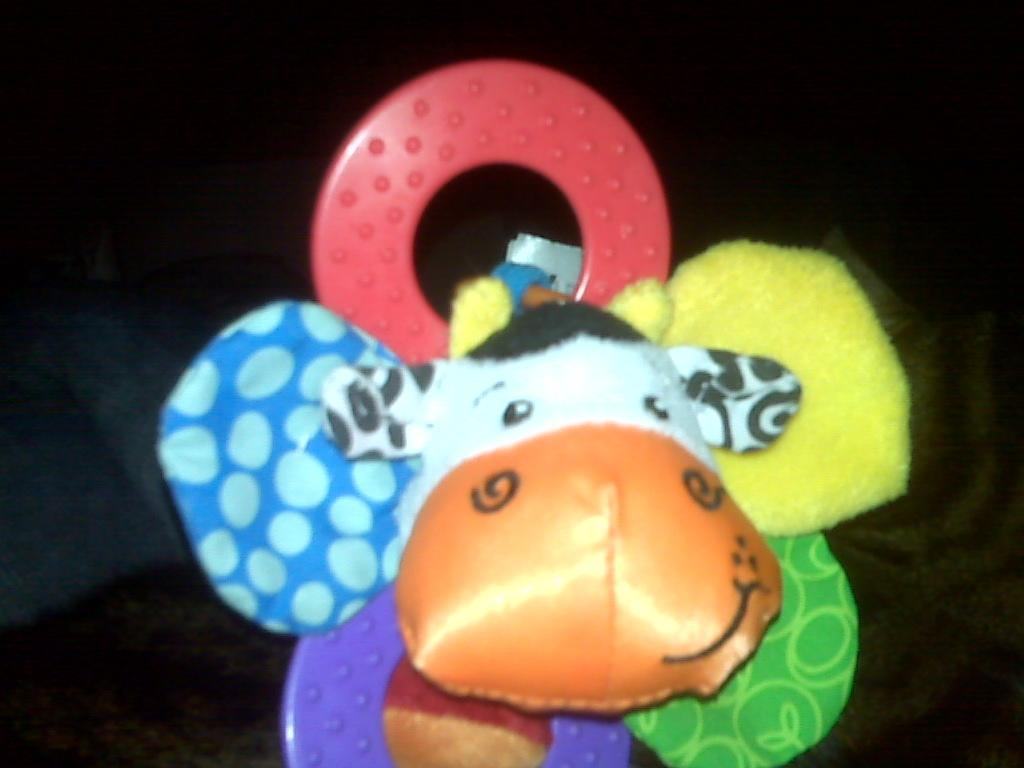What is the main subject of the image? The main subject of the image is a doll. What type of shade is the woman sitting under in the image? There is no woman or shade present in the image; it only features a doll. 